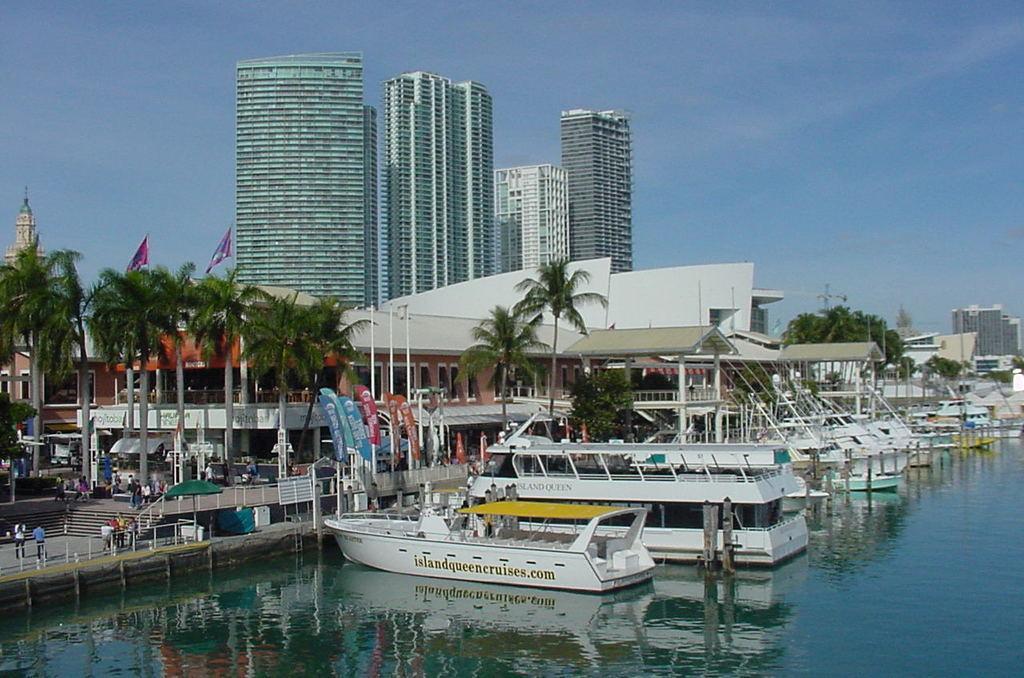Can you describe this image briefly? In this picture I can observe boats floating on the water. I can observe trees on the left side. In the background there are some buildings and sky. 